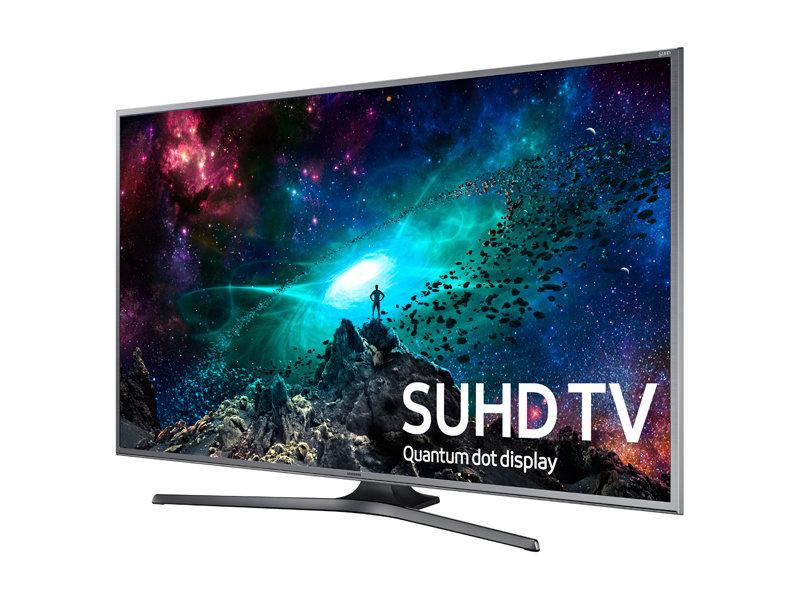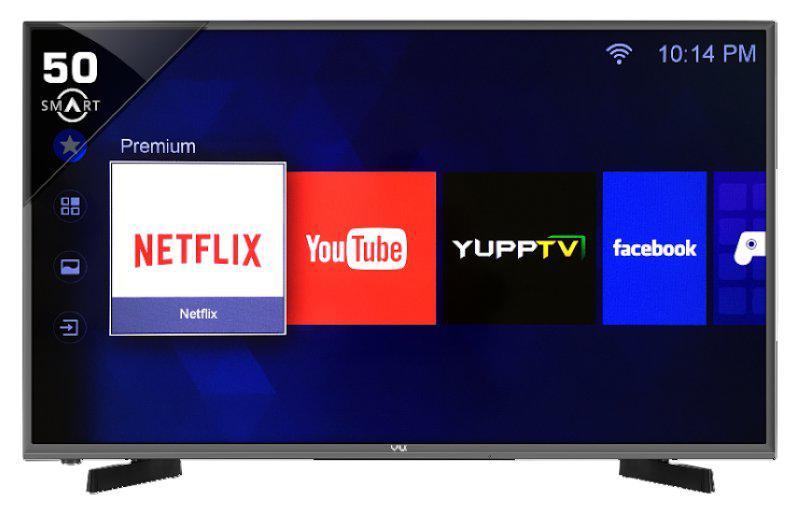The first image is the image on the left, the second image is the image on the right. Considering the images on both sides, is "At least one television has two legs." valid? Answer yes or no. Yes. The first image is the image on the left, the second image is the image on the right. Given the left and right images, does the statement "There are apps displayed on the television." hold true? Answer yes or no. No. 